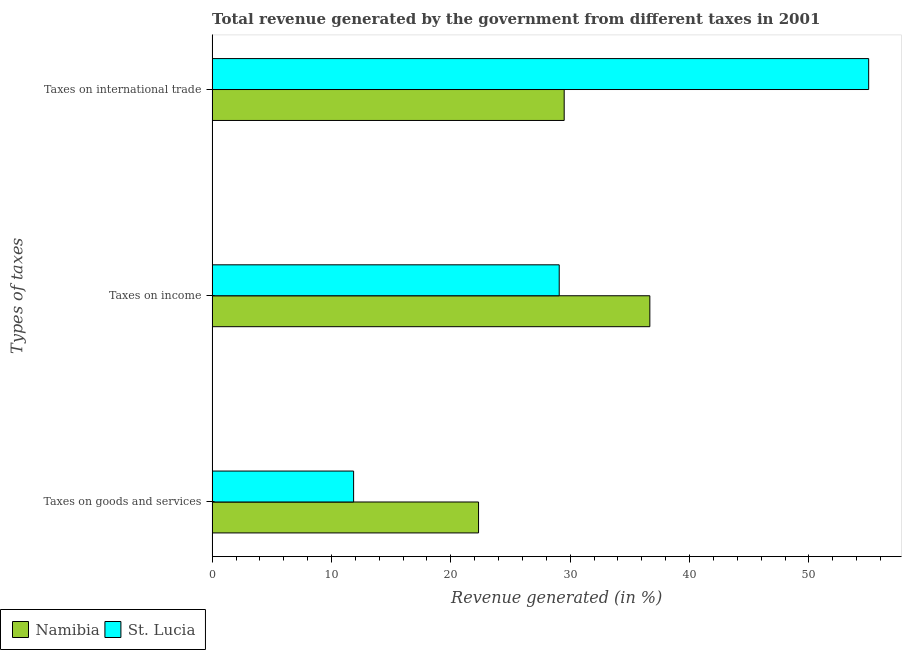How many different coloured bars are there?
Your response must be concise. 2. How many groups of bars are there?
Provide a short and direct response. 3. Are the number of bars per tick equal to the number of legend labels?
Give a very brief answer. Yes. Are the number of bars on each tick of the Y-axis equal?
Your response must be concise. Yes. How many bars are there on the 1st tick from the top?
Your answer should be very brief. 2. What is the label of the 1st group of bars from the top?
Keep it short and to the point. Taxes on international trade. What is the percentage of revenue generated by taxes on goods and services in St. Lucia?
Provide a succinct answer. 11.85. Across all countries, what is the maximum percentage of revenue generated by taxes on income?
Make the answer very short. 36.67. Across all countries, what is the minimum percentage of revenue generated by tax on international trade?
Your answer should be very brief. 29.49. In which country was the percentage of revenue generated by tax on international trade maximum?
Give a very brief answer. St. Lucia. In which country was the percentage of revenue generated by tax on international trade minimum?
Make the answer very short. Namibia. What is the total percentage of revenue generated by tax on international trade in the graph?
Provide a short and direct response. 84.5. What is the difference between the percentage of revenue generated by taxes on goods and services in Namibia and that in St. Lucia?
Provide a succinct answer. 10.47. What is the difference between the percentage of revenue generated by tax on international trade in Namibia and the percentage of revenue generated by taxes on goods and services in St. Lucia?
Your answer should be compact. 17.64. What is the average percentage of revenue generated by taxes on goods and services per country?
Your answer should be very brief. 17.09. What is the difference between the percentage of revenue generated by taxes on income and percentage of revenue generated by tax on international trade in St. Lucia?
Ensure brevity in your answer.  -25.92. In how many countries, is the percentage of revenue generated by taxes on income greater than 42 %?
Your answer should be compact. 0. What is the ratio of the percentage of revenue generated by tax on international trade in Namibia to that in St. Lucia?
Your answer should be very brief. 0.54. Is the difference between the percentage of revenue generated by tax on international trade in Namibia and St. Lucia greater than the difference between the percentage of revenue generated by taxes on goods and services in Namibia and St. Lucia?
Provide a short and direct response. No. What is the difference between the highest and the second highest percentage of revenue generated by taxes on goods and services?
Give a very brief answer. 10.47. What is the difference between the highest and the lowest percentage of revenue generated by taxes on goods and services?
Give a very brief answer. 10.47. Is the sum of the percentage of revenue generated by tax on international trade in St. Lucia and Namibia greater than the maximum percentage of revenue generated by taxes on income across all countries?
Provide a short and direct response. Yes. What does the 1st bar from the top in Taxes on goods and services represents?
Your answer should be compact. St. Lucia. What does the 1st bar from the bottom in Taxes on international trade represents?
Ensure brevity in your answer.  Namibia. Are all the bars in the graph horizontal?
Offer a very short reply. Yes. How many countries are there in the graph?
Provide a short and direct response. 2. Are the values on the major ticks of X-axis written in scientific E-notation?
Keep it short and to the point. No. Does the graph contain any zero values?
Your response must be concise. No. Does the graph contain grids?
Your answer should be very brief. No. How many legend labels are there?
Provide a short and direct response. 2. What is the title of the graph?
Your answer should be compact. Total revenue generated by the government from different taxes in 2001. Does "Ghana" appear as one of the legend labels in the graph?
Keep it short and to the point. No. What is the label or title of the X-axis?
Offer a very short reply. Revenue generated (in %). What is the label or title of the Y-axis?
Make the answer very short. Types of taxes. What is the Revenue generated (in %) of Namibia in Taxes on goods and services?
Keep it short and to the point. 22.32. What is the Revenue generated (in %) of St. Lucia in Taxes on goods and services?
Offer a very short reply. 11.85. What is the Revenue generated (in %) of Namibia in Taxes on income?
Your answer should be very brief. 36.67. What is the Revenue generated (in %) of St. Lucia in Taxes on income?
Give a very brief answer. 29.08. What is the Revenue generated (in %) of Namibia in Taxes on international trade?
Provide a short and direct response. 29.49. What is the Revenue generated (in %) in St. Lucia in Taxes on international trade?
Make the answer very short. 55. Across all Types of taxes, what is the maximum Revenue generated (in %) in Namibia?
Offer a very short reply. 36.67. Across all Types of taxes, what is the maximum Revenue generated (in %) in St. Lucia?
Your response must be concise. 55. Across all Types of taxes, what is the minimum Revenue generated (in %) in Namibia?
Offer a very short reply. 22.32. Across all Types of taxes, what is the minimum Revenue generated (in %) in St. Lucia?
Offer a terse response. 11.85. What is the total Revenue generated (in %) in Namibia in the graph?
Offer a terse response. 88.49. What is the total Revenue generated (in %) in St. Lucia in the graph?
Your answer should be very brief. 95.93. What is the difference between the Revenue generated (in %) in Namibia in Taxes on goods and services and that in Taxes on income?
Your answer should be compact. -14.35. What is the difference between the Revenue generated (in %) of St. Lucia in Taxes on goods and services and that in Taxes on income?
Ensure brevity in your answer.  -17.22. What is the difference between the Revenue generated (in %) of Namibia in Taxes on goods and services and that in Taxes on international trade?
Offer a terse response. -7.18. What is the difference between the Revenue generated (in %) in St. Lucia in Taxes on goods and services and that in Taxes on international trade?
Provide a short and direct response. -43.15. What is the difference between the Revenue generated (in %) in Namibia in Taxes on income and that in Taxes on international trade?
Your response must be concise. 7.18. What is the difference between the Revenue generated (in %) of St. Lucia in Taxes on income and that in Taxes on international trade?
Your answer should be compact. -25.92. What is the difference between the Revenue generated (in %) in Namibia in Taxes on goods and services and the Revenue generated (in %) in St. Lucia in Taxes on income?
Keep it short and to the point. -6.76. What is the difference between the Revenue generated (in %) in Namibia in Taxes on goods and services and the Revenue generated (in %) in St. Lucia in Taxes on international trade?
Ensure brevity in your answer.  -32.68. What is the difference between the Revenue generated (in %) in Namibia in Taxes on income and the Revenue generated (in %) in St. Lucia in Taxes on international trade?
Keep it short and to the point. -18.33. What is the average Revenue generated (in %) in Namibia per Types of taxes?
Your response must be concise. 29.5. What is the average Revenue generated (in %) in St. Lucia per Types of taxes?
Give a very brief answer. 31.98. What is the difference between the Revenue generated (in %) of Namibia and Revenue generated (in %) of St. Lucia in Taxes on goods and services?
Make the answer very short. 10.47. What is the difference between the Revenue generated (in %) of Namibia and Revenue generated (in %) of St. Lucia in Taxes on income?
Offer a very short reply. 7.59. What is the difference between the Revenue generated (in %) in Namibia and Revenue generated (in %) in St. Lucia in Taxes on international trade?
Your answer should be very brief. -25.51. What is the ratio of the Revenue generated (in %) of Namibia in Taxes on goods and services to that in Taxes on income?
Offer a terse response. 0.61. What is the ratio of the Revenue generated (in %) in St. Lucia in Taxes on goods and services to that in Taxes on income?
Offer a very short reply. 0.41. What is the ratio of the Revenue generated (in %) of Namibia in Taxes on goods and services to that in Taxes on international trade?
Your answer should be very brief. 0.76. What is the ratio of the Revenue generated (in %) in St. Lucia in Taxes on goods and services to that in Taxes on international trade?
Offer a terse response. 0.22. What is the ratio of the Revenue generated (in %) in Namibia in Taxes on income to that in Taxes on international trade?
Ensure brevity in your answer.  1.24. What is the ratio of the Revenue generated (in %) of St. Lucia in Taxes on income to that in Taxes on international trade?
Make the answer very short. 0.53. What is the difference between the highest and the second highest Revenue generated (in %) of Namibia?
Your answer should be compact. 7.18. What is the difference between the highest and the second highest Revenue generated (in %) of St. Lucia?
Your response must be concise. 25.92. What is the difference between the highest and the lowest Revenue generated (in %) in Namibia?
Make the answer very short. 14.35. What is the difference between the highest and the lowest Revenue generated (in %) of St. Lucia?
Keep it short and to the point. 43.15. 